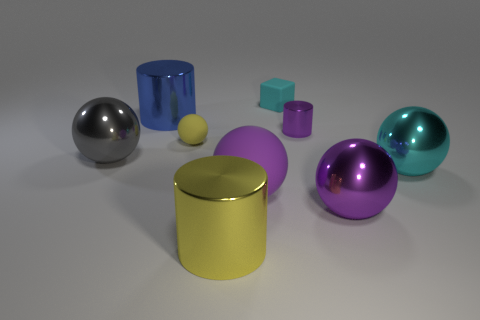How many big things have the same color as the small sphere?
Provide a short and direct response. 1. There is a big gray metal thing left of the big cyan metal thing; does it have the same shape as the small matte object that is behind the big blue metal cylinder?
Your answer should be very brief. No. How many large purple spheres are left of the metallic cylinder on the left side of the metal cylinder in front of the big gray ball?
Your response must be concise. 0. What is the material of the yellow object that is behind the sphere that is to the left of the blue cylinder that is behind the gray metallic object?
Make the answer very short. Rubber. Do the large sphere on the left side of the yellow rubber thing and the tiny cyan object have the same material?
Provide a short and direct response. No. How many yellow rubber cubes are the same size as the purple matte sphere?
Offer a very short reply. 0. Is the number of gray spheres right of the big purple matte sphere greater than the number of small yellow balls in front of the small metallic cylinder?
Make the answer very short. No. Is there a large cyan rubber thing of the same shape as the blue object?
Keep it short and to the point. No. What size is the purple sphere to the left of the purple shiny object in front of the cyan sphere?
Offer a terse response. Large. What is the shape of the large yellow metal thing that is in front of the small yellow thing on the left side of the cyan object behind the blue object?
Offer a terse response. Cylinder. 